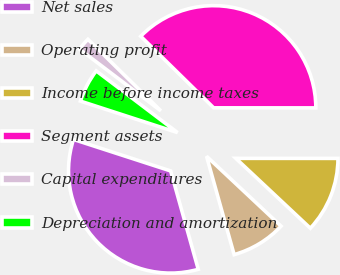<chart> <loc_0><loc_0><loc_500><loc_500><pie_chart><fcel>Net sales<fcel>Operating profit<fcel>Income before income taxes<fcel>Segment assets<fcel>Capital expenditures<fcel>Depreciation and amortization<nl><fcel>34.34%<fcel>8.66%<fcel>11.98%<fcel>37.66%<fcel>2.02%<fcel>5.34%<nl></chart> 